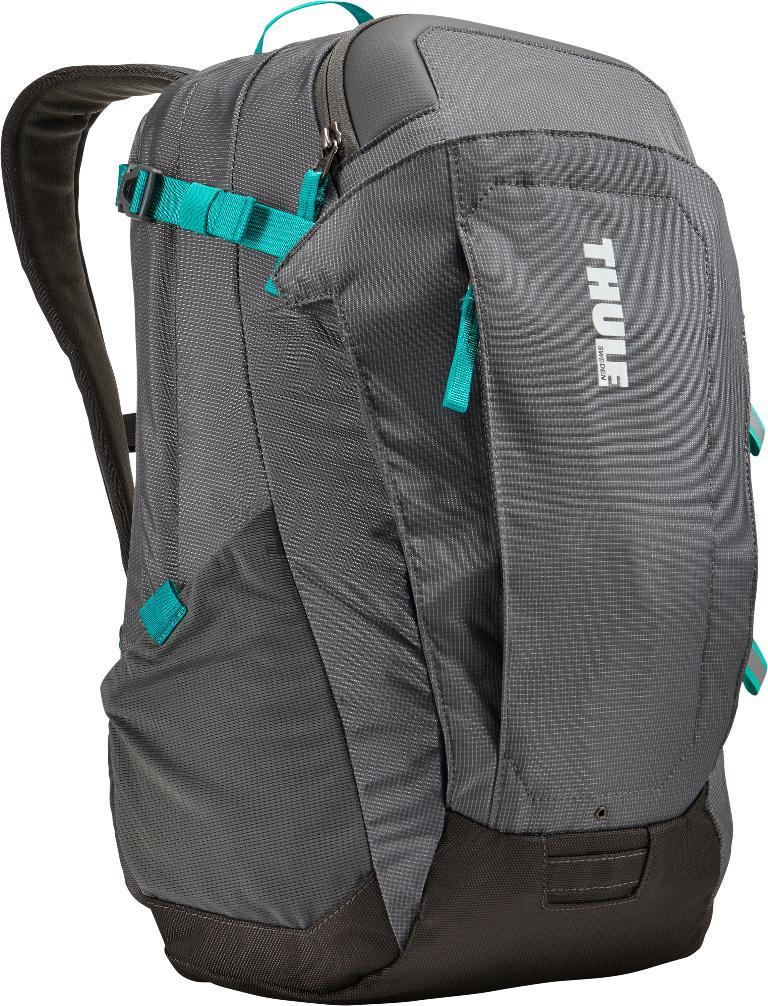<image>
Offer a succinct explanation of the picture presented. A Thule brand backpack from Sweden colored gray and black with teal.colored straps. 